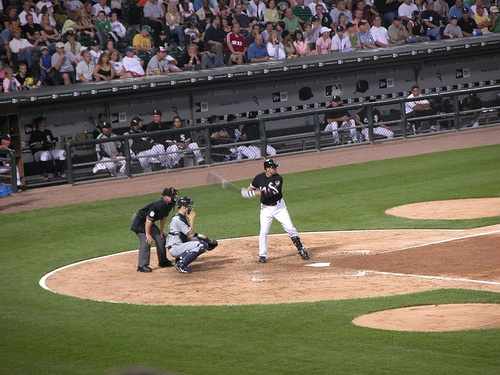Describe the objects in this image and their specific colors. I can see people in gray, black, and darkgray tones, people in gray, lavender, black, and darkgray tones, people in gray and black tones, people in gray, black, lavender, and darkgray tones, and people in gray, black, and lavender tones in this image. 